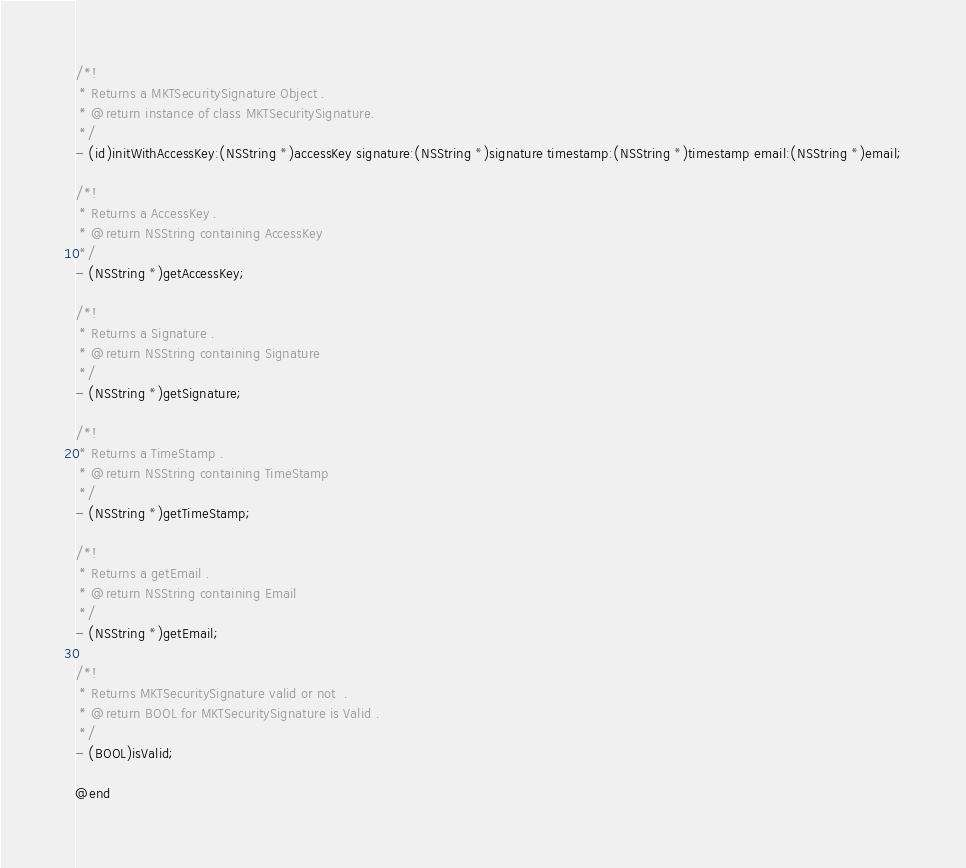Convert code to text. <code><loc_0><loc_0><loc_500><loc_500><_C_>/*!
 * Returns a MKTSecuritySignature Object .
 * @return instance of class MKTSecuritySignature.
 */
- (id)initWithAccessKey:(NSString *)accessKey signature:(NSString *)signature timestamp:(NSString *)timestamp email:(NSString *)email;

/*!
 * Returns a AccessKey .
 * @return NSString containing AccessKey
 */
- (NSString *)getAccessKey;

/*!
 * Returns a Signature .
 * @return NSString containing Signature
 */
- (NSString *)getSignature;

/*!
 * Returns a TimeStamp .
 * @return NSString containing TimeStamp
 */
- (NSString *)getTimeStamp;

/*!
 * Returns a getEmail .
 * @return NSString containing Email
 */
- (NSString *)getEmail;

/*!
 * Returns MKTSecuritySignature valid or not  .
 * @return BOOL for MKTSecuritySignature is Valid .
 */
- (BOOL)isValid;

@end
</code> 